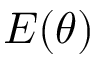Convert formula to latex. <formula><loc_0><loc_0><loc_500><loc_500>E ( \theta )</formula> 